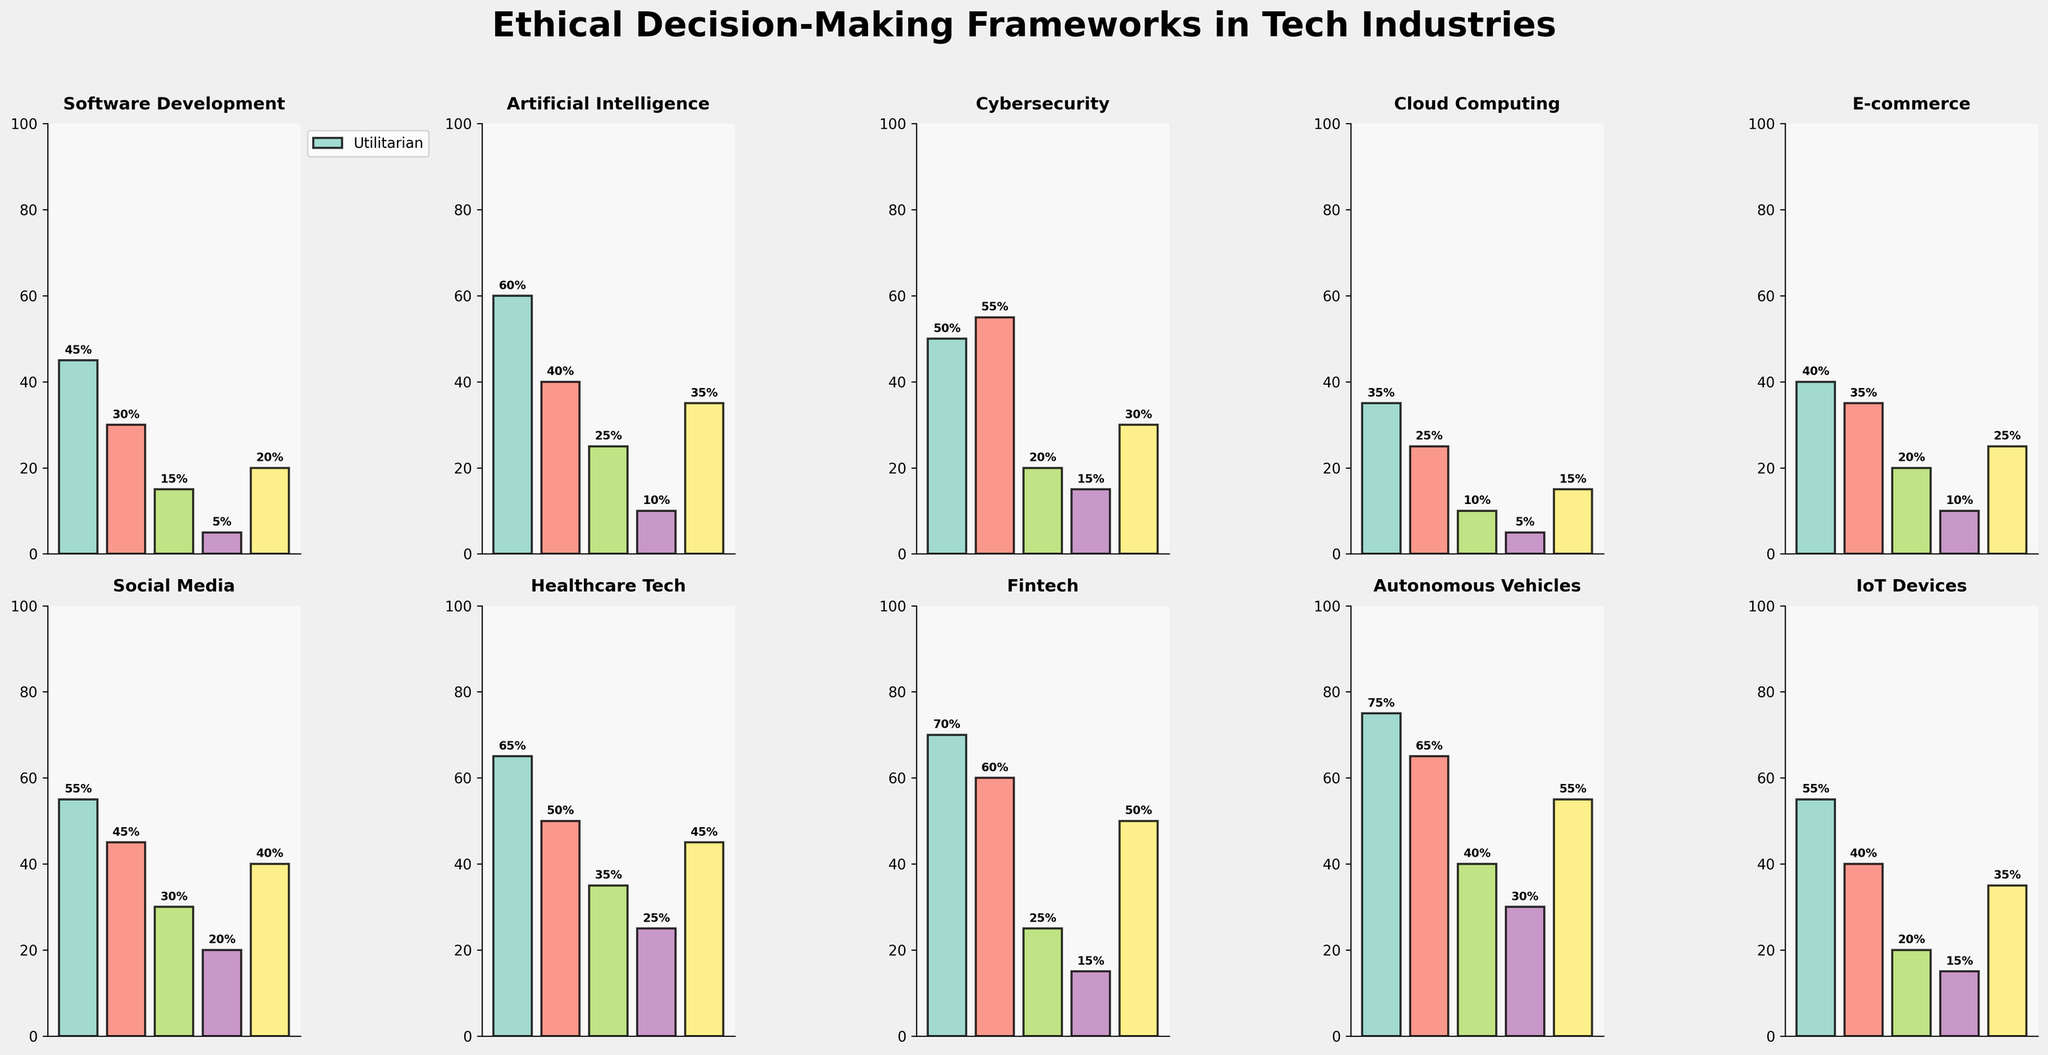what is the industry sector with the highest usage of utilitarian framework? The figure shows the bar heights for different ethical frameworks in various industries. For the highest usage of the utilitarian framework, you look for the tallest bar in the "Utilitarian" category. The tallest bar is for the "Autonomous Vehicles" sector.
Answer: Autonomous Vehicles Which industry sector utilizes the virtue ethics framework the least? Examine the bars representing the virtue ethics framework in each subplot. The smallest bar corresponds to the "Cloud Computing" sector.
Answer: Cloud Computing What is the difference in the usage of the care ethics framework between Healthcare Tech and Fintech? To find the difference, look at the heights of the bars for the care ethics framework in both the Healthcare Tech and Fintech subplots. Subtract the value for Fintech from the value for Healthcare Tech: 25 - 15 = 10.
Answer: 10 Which industry sector has the most balanced usage of different ethical frameworks? Check the subplots and identify which industry has bars of nearly equal height across all ethical frameworks. The "IoT Devices" sector appears to have the most balanced usage.
Answer: IoT Devices In which industry sector does social contract theory have the most significant representation? Identify the highest bar in all the subplots representing the social contract theory framework. The tallest bar corresponds to the "Autonomous Vehicles" sector.
Answer: Autonomous Vehicles What is the combined usage percentage of utilitarian and virtue ethics frameworks in the Artificial Intelligence sector? First, locate the bars representing Utilitarian (60%) and Virtue Ethics (25%) in the Artificial Intelligence subplot. Add these percentages: 60 + 25 = 85.
Answer: 85 Which two frameworks have the closest usage percentages in the E-commerce sector? In the E-commerce subplot, compare the bar heights: Utilitarian (40%), Deontological (35%), Virtue Ethics (20%), Care Ethics (10%), and Social Contract Theory (25%). The closest usage percentages are Utilitarian (40%) and Deontological (35%), with a difference of 5%.
Answer: Utilitarian and Deontological 